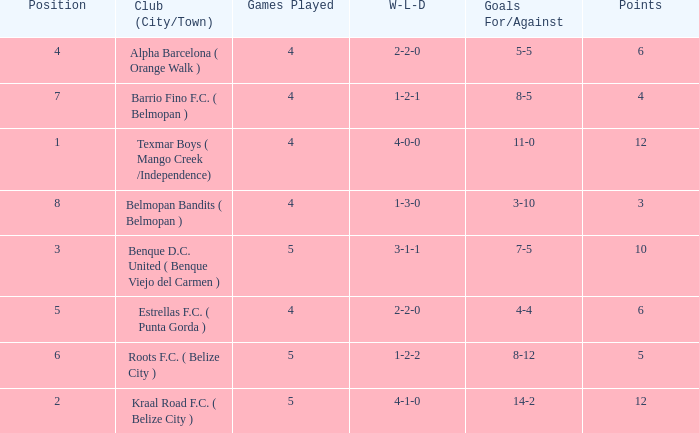Who is the the club (city/town) with goals for/against being 14-2 Kraal Road F.C. ( Belize City ). 